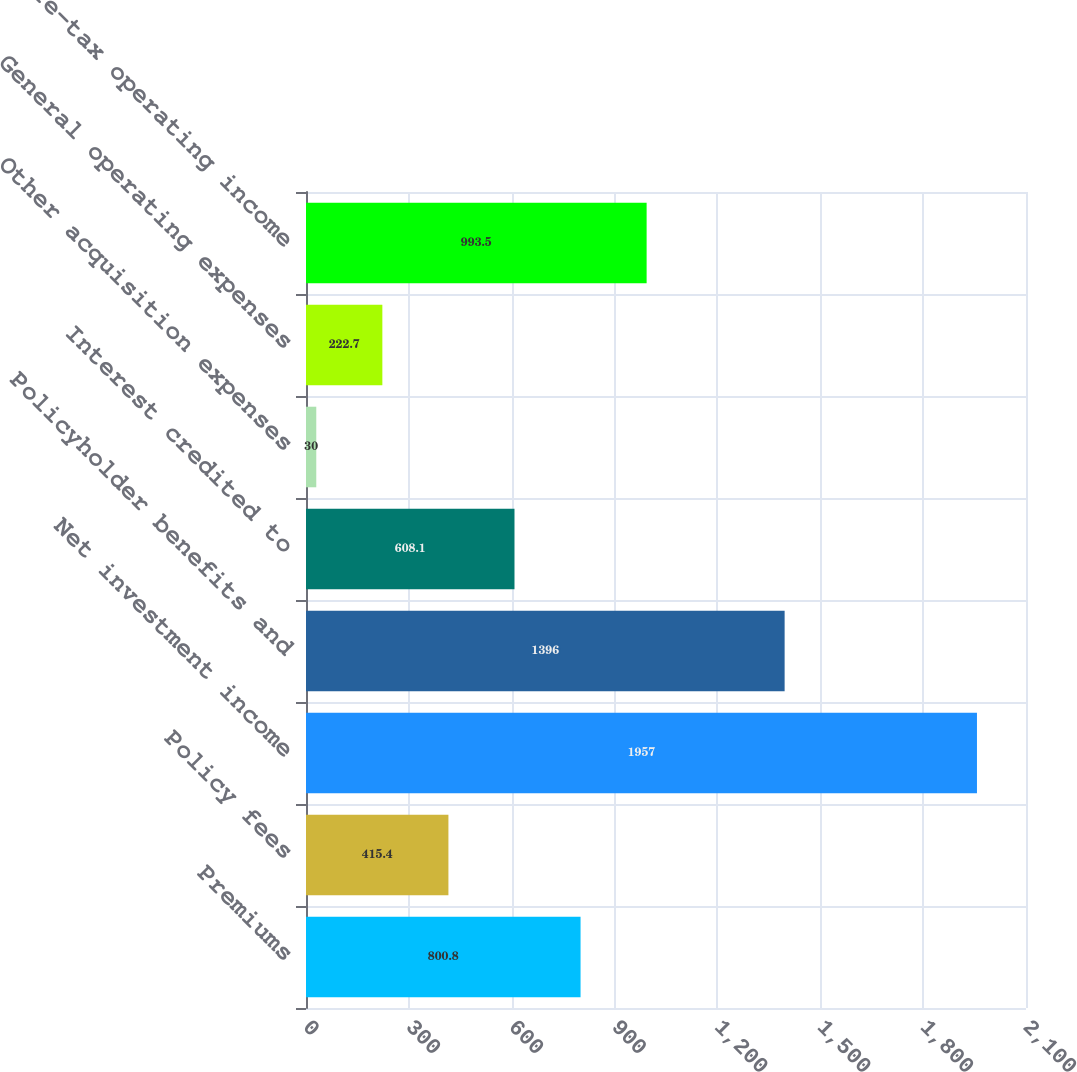Convert chart. <chart><loc_0><loc_0><loc_500><loc_500><bar_chart><fcel>Premiums<fcel>Policy fees<fcel>Net investment income<fcel>Policyholder benefits and<fcel>Interest credited to<fcel>Other acquisition expenses<fcel>General operating expenses<fcel>Pre-tax operating income<nl><fcel>800.8<fcel>415.4<fcel>1957<fcel>1396<fcel>608.1<fcel>30<fcel>222.7<fcel>993.5<nl></chart> 